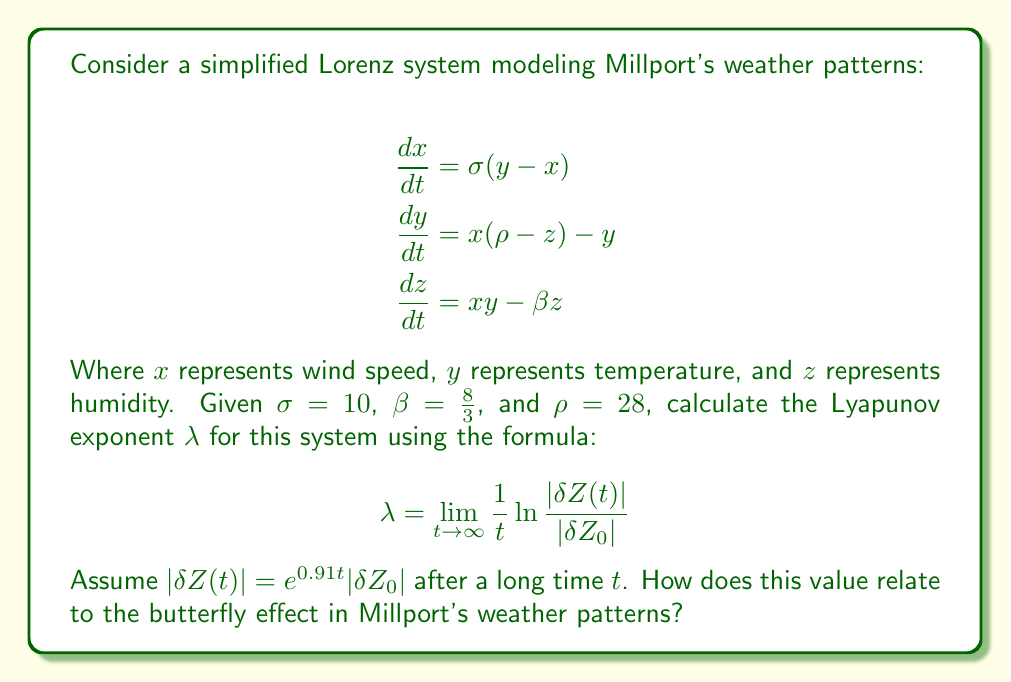Can you answer this question? To solve this problem, we'll follow these steps:

1) Recall the formula for the Lyapunov exponent:

   $$\lambda = \lim_{t \to \infty} \frac{1}{t} \ln \frac{|\delta Z(t)|}{|\delta Z_0|}$$

2) We're given that $|\delta Z(t)| = e^{0.91t}|\delta Z_0|$ after a long time $t$. Let's substitute this into the formula:

   $$\lambda = \lim_{t \to \infty} \frac{1}{t} \ln \frac{e^{0.91t}|\delta Z_0|}{|\delta Z_0|}$$

3) Simplify the fraction inside the logarithm:

   $$\lambda = \lim_{t \to \infty} \frac{1}{t} \ln (e^{0.91t})$$

4) Use the property of logarithms: $\ln(e^x) = x$

   $$\lambda = \lim_{t \to \infty} \frac{1}{t} (0.91t)$$

5) Simplify:

   $$\lambda = \lim_{t \to \infty} 0.91 = 0.91$$

6) Interpretation: The positive Lyapunov exponent (λ > 0) indicates that the system is chaotic. This means that small changes in initial conditions can lead to significantly different outcomes over time, which is the essence of the butterfly effect.

7) In the context of Millport's weather patterns, this suggests that a small perturbation (like a butterfly flapping its wings) could potentially lead to large-scale changes in the weather over time. This makes long-term weather prediction in Millport challenging and highlights the sensitivity of the local climate system to small disturbances.
Answer: $\lambda = 0.91$, indicating chaotic behavior and high sensitivity to initial conditions in Millport's weather patterns. 